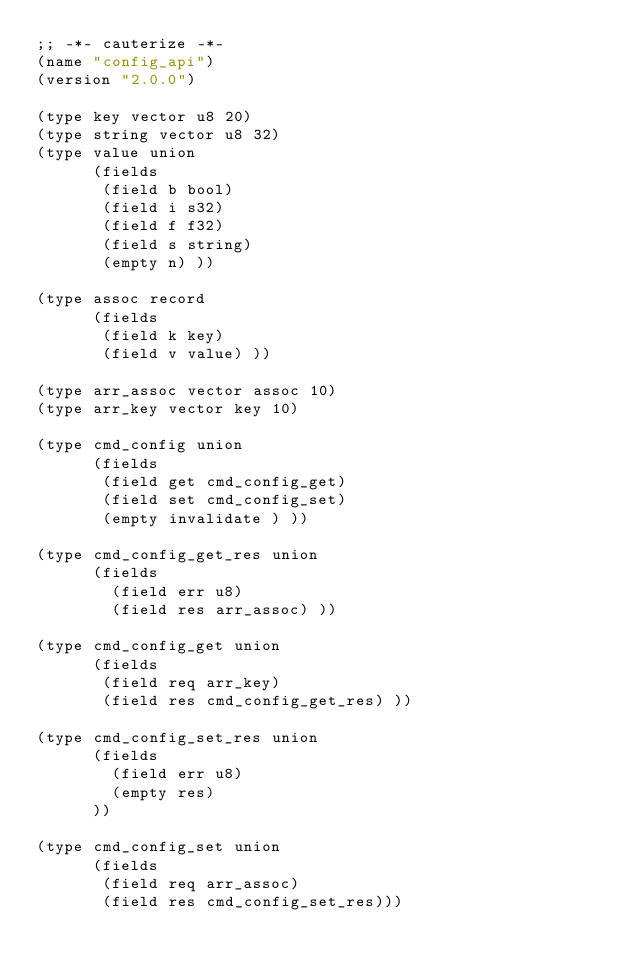<code> <loc_0><loc_0><loc_500><loc_500><_Scheme_>;; -*- cauterize -*-
(name "config_api")
(version "2.0.0")

(type key vector u8 20)
(type string vector u8 32)
(type value union
      (fields
       (field b bool)
       (field i s32)
       (field f f32)
       (field s string)
       (empty n) ))

(type assoc record
      (fields
       (field k key)
       (field v value) ))

(type arr_assoc vector assoc 10)
(type arr_key vector key 10)

(type cmd_config union
      (fields
       (field get cmd_config_get)
       (field set cmd_config_set)
       (empty invalidate ) ))

(type cmd_config_get_res union
      (fields
        (field err u8)
        (field res arr_assoc) ))

(type cmd_config_get union
      (fields
       (field req arr_key)
       (field res cmd_config_get_res) ))

(type cmd_config_set_res union
      (fields
        (field err u8)
        (empty res)
      ))

(type cmd_config_set union
      (fields
       (field req arr_assoc)
       (field res cmd_config_set_res)))

</code> 